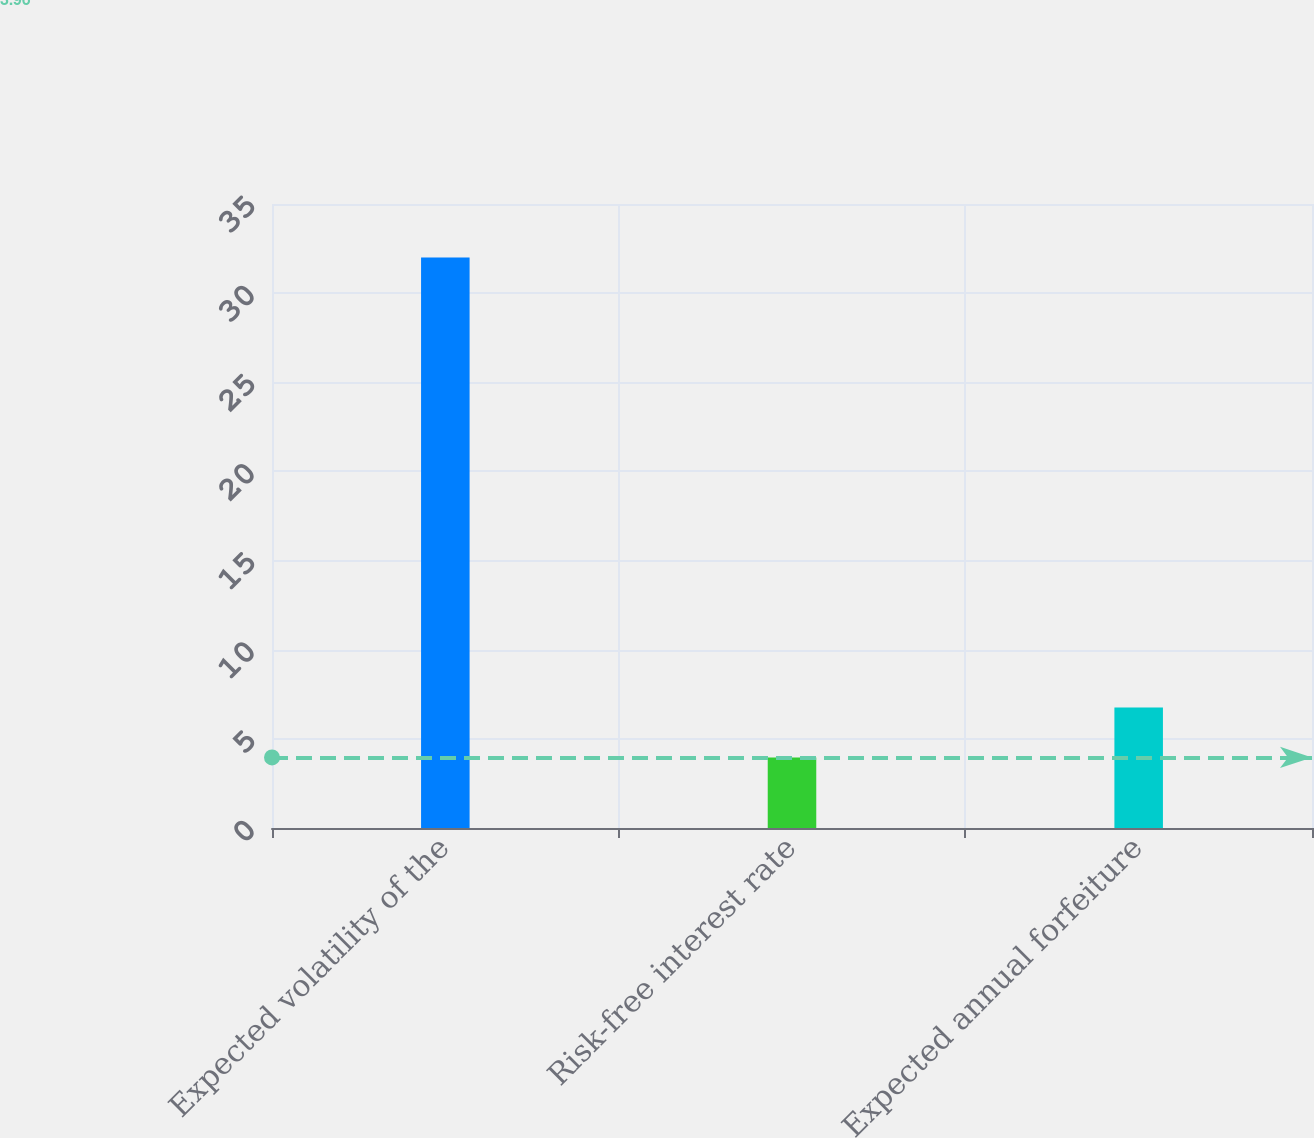<chart> <loc_0><loc_0><loc_500><loc_500><bar_chart><fcel>Expected volatility of the<fcel>Risk-free interest rate<fcel>Expected annual forfeiture<nl><fcel>32<fcel>3.96<fcel>6.76<nl></chart> 